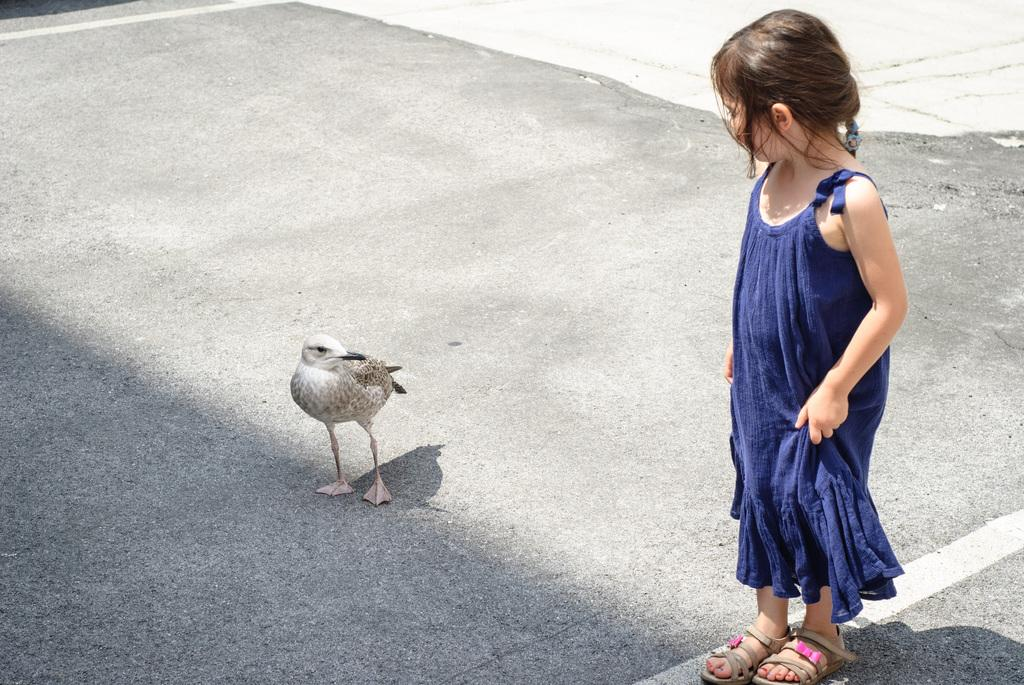What animal can be seen on the road in the image? There is a bird on the road in the image. What is the position of the girl in the image? The girl is standing on the right side of the image. How many toes can be seen on the bird in the image? There is no information about the bird's toes in the image, so it cannot be determined. 